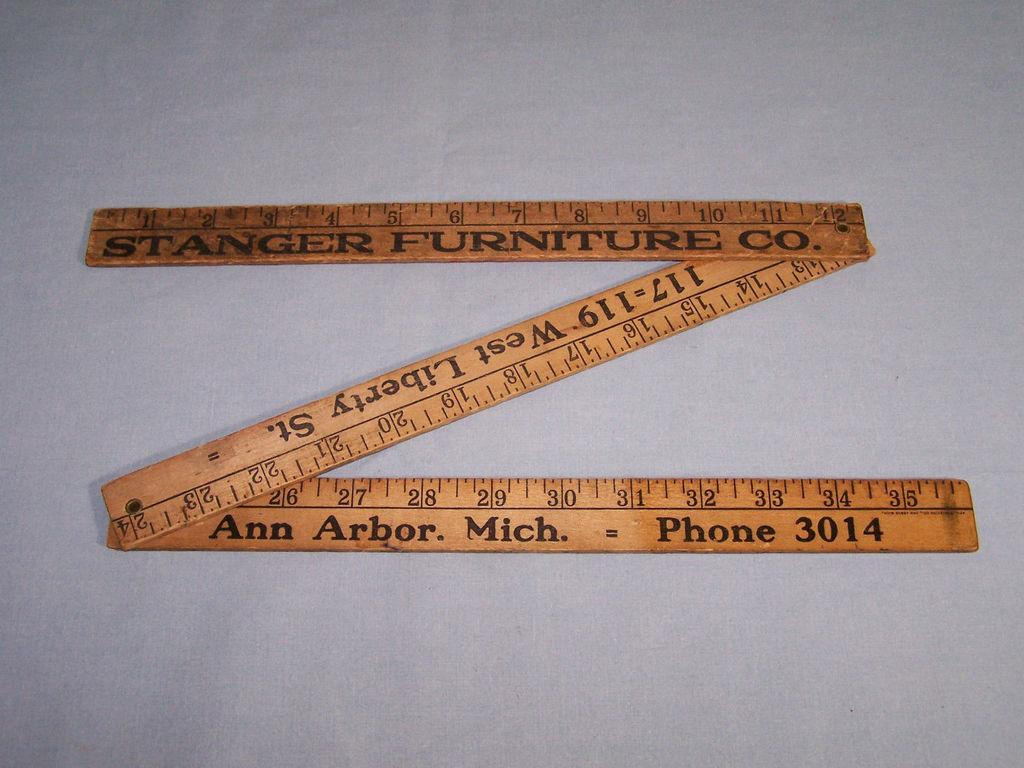<image>
Provide a brief description of the given image. The Stranger Furniture Co. ruler will fold and unfold to three feet. 